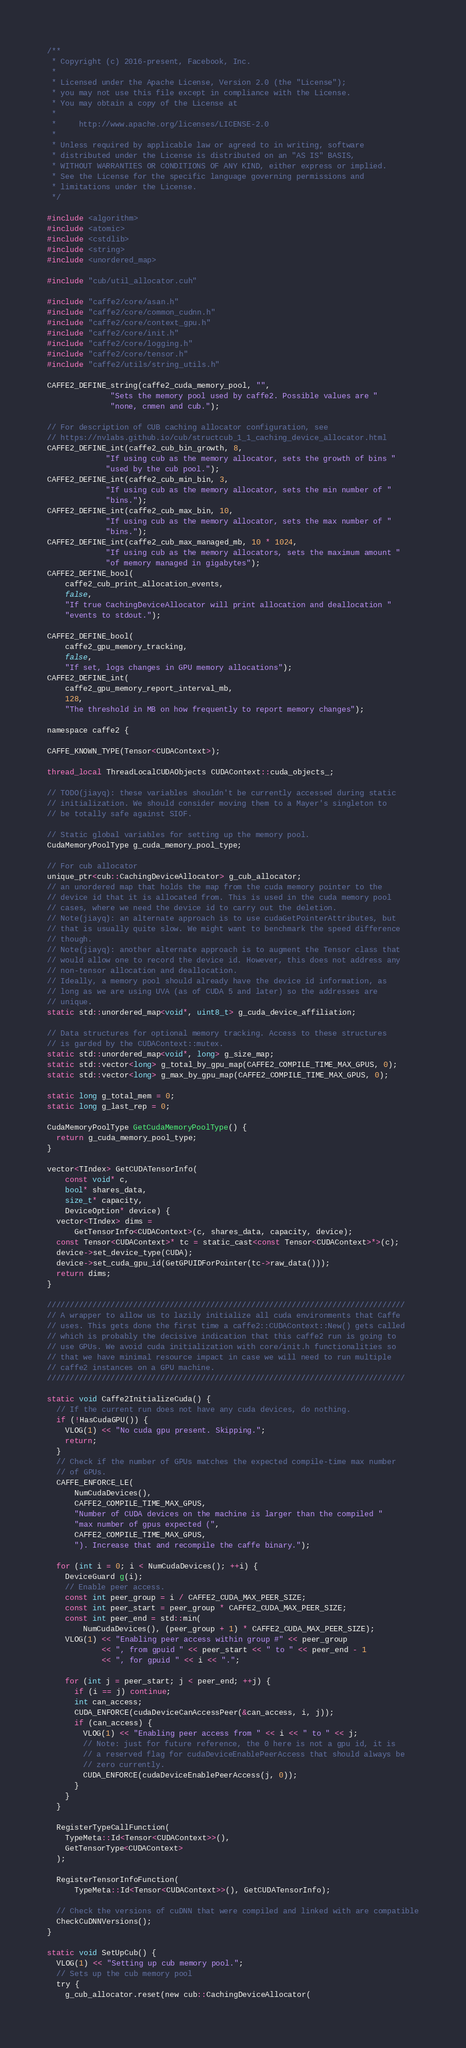Convert code to text. <code><loc_0><loc_0><loc_500><loc_500><_Cuda_>/**
 * Copyright (c) 2016-present, Facebook, Inc.
 *
 * Licensed under the Apache License, Version 2.0 (the "License");
 * you may not use this file except in compliance with the License.
 * You may obtain a copy of the License at
 *
 *     http://www.apache.org/licenses/LICENSE-2.0
 *
 * Unless required by applicable law or agreed to in writing, software
 * distributed under the License is distributed on an "AS IS" BASIS,
 * WITHOUT WARRANTIES OR CONDITIONS OF ANY KIND, either express or implied.
 * See the License for the specific language governing permissions and
 * limitations under the License.
 */

#include <algorithm>
#include <atomic>
#include <cstdlib>
#include <string>
#include <unordered_map>

#include "cub/util_allocator.cuh"

#include "caffe2/core/asan.h"
#include "caffe2/core/common_cudnn.h"
#include "caffe2/core/context_gpu.h"
#include "caffe2/core/init.h"
#include "caffe2/core/logging.h"
#include "caffe2/core/tensor.h"
#include "caffe2/utils/string_utils.h"

CAFFE2_DEFINE_string(caffe2_cuda_memory_pool, "",
              "Sets the memory pool used by caffe2. Possible values are "
              "none, cnmen and cub.");

// For description of CUB caching allocator configuration, see
// https://nvlabs.github.io/cub/structcub_1_1_caching_device_allocator.html
CAFFE2_DEFINE_int(caffe2_cub_bin_growth, 8,
             "If using cub as the memory allocator, sets the growth of bins "
             "used by the cub pool.");
CAFFE2_DEFINE_int(caffe2_cub_min_bin, 3,
             "If using cub as the memory allocator, sets the min number of "
             "bins.");
CAFFE2_DEFINE_int(caffe2_cub_max_bin, 10,
             "If using cub as the memory allocator, sets the max number of "
             "bins.");
CAFFE2_DEFINE_int(caffe2_cub_max_managed_mb, 10 * 1024,
             "If using cub as the memory allocators, sets the maximum amount "
             "of memory managed in gigabytes");
CAFFE2_DEFINE_bool(
    caffe2_cub_print_allocation_events,
    false,
    "If true CachingDeviceAllocator will print allocation and deallocation "
    "events to stdout.");

CAFFE2_DEFINE_bool(
    caffe2_gpu_memory_tracking,
    false,
    "If set, logs changes in GPU memory allocations");
CAFFE2_DEFINE_int(
    caffe2_gpu_memory_report_interval_mb,
    128,
    "The threshold in MB on how frequently to report memory changes");

namespace caffe2 {

CAFFE_KNOWN_TYPE(Tensor<CUDAContext>);

thread_local ThreadLocalCUDAObjects CUDAContext::cuda_objects_;

// TODO(jiayq): these variables shouldn't be currently accessed during static
// initialization. We should consider moving them to a Mayer's singleton to
// be totally safe against SIOF.

// Static global variables for setting up the memory pool.
CudaMemoryPoolType g_cuda_memory_pool_type;

// For cub allocator
unique_ptr<cub::CachingDeviceAllocator> g_cub_allocator;
// an unordered map that holds the map from the cuda memory pointer to the
// device id that it is allocated from. This is used in the cuda memory pool
// cases, where we need the device id to carry out the deletion.
// Note(jiayq): an alternate approach is to use cudaGetPointerAttributes, but
// that is usually quite slow. We might want to benchmark the speed difference
// though.
// Note(jiayq): another alternate approach is to augment the Tensor class that
// would allow one to record the device id. However, this does not address any
// non-tensor allocation and deallocation.
// Ideally, a memory pool should already have the device id information, as
// long as we are using UVA (as of CUDA 5 and later) so the addresses are
// unique.
static std::unordered_map<void*, uint8_t> g_cuda_device_affiliation;

// Data structures for optional memory tracking. Access to these structures
// is garded by the CUDAContext::mutex.
static std::unordered_map<void*, long> g_size_map;
static std::vector<long> g_total_by_gpu_map(CAFFE2_COMPILE_TIME_MAX_GPUS, 0);
static std::vector<long> g_max_by_gpu_map(CAFFE2_COMPILE_TIME_MAX_GPUS, 0);

static long g_total_mem = 0;
static long g_last_rep = 0;

CudaMemoryPoolType GetCudaMemoryPoolType() {
  return g_cuda_memory_pool_type;
}

vector<TIndex> GetCUDATensorInfo(
    const void* c,
    bool* shares_data,
    size_t* capacity,
    DeviceOption* device) {
  vector<TIndex> dims =
      GetTensorInfo<CUDAContext>(c, shares_data, capacity, device);
  const Tensor<CUDAContext>* tc = static_cast<const Tensor<CUDAContext>*>(c);
  device->set_device_type(CUDA);
  device->set_cuda_gpu_id(GetGPUIDForPointer(tc->raw_data()));
  return dims;
}

///////////////////////////////////////////////////////////////////////////////
// A wrapper to allow us to lazily initialize all cuda environments that Caffe
// uses. This gets done the first time a caffe2::CUDAContext::New() gets called
// which is probably the decisive indication that this caffe2 run is going to
// use GPUs. We avoid cuda initialization with core/init.h functionalities so
// that we have minimal resource impact in case we will need to run multiple
// caffe2 instances on a GPU machine.
///////////////////////////////////////////////////////////////////////////////

static void Caffe2InitializeCuda() {
  // If the current run does not have any cuda devices, do nothing.
  if (!HasCudaGPU()) {
    VLOG(1) << "No cuda gpu present. Skipping.";
    return;
  }
  // Check if the number of GPUs matches the expected compile-time max number
  // of GPUs.
  CAFFE_ENFORCE_LE(
      NumCudaDevices(),
      CAFFE2_COMPILE_TIME_MAX_GPUS,
      "Number of CUDA devices on the machine is larger than the compiled "
      "max number of gpus expected (",
      CAFFE2_COMPILE_TIME_MAX_GPUS,
      "). Increase that and recompile the caffe binary.");

  for (int i = 0; i < NumCudaDevices(); ++i) {
    DeviceGuard g(i);
    // Enable peer access.
    const int peer_group = i / CAFFE2_CUDA_MAX_PEER_SIZE;
    const int peer_start = peer_group * CAFFE2_CUDA_MAX_PEER_SIZE;
    const int peer_end = std::min(
        NumCudaDevices(), (peer_group + 1) * CAFFE2_CUDA_MAX_PEER_SIZE);
    VLOG(1) << "Enabling peer access within group #" << peer_group
            << ", from gpuid " << peer_start << " to " << peer_end - 1
            << ", for gpuid " << i << ".";

    for (int j = peer_start; j < peer_end; ++j) {
      if (i == j) continue;
      int can_access;
      CUDA_ENFORCE(cudaDeviceCanAccessPeer(&can_access, i, j));
      if (can_access) {
        VLOG(1) << "Enabling peer access from " << i << " to " << j;
        // Note: just for future reference, the 0 here is not a gpu id, it is
        // a reserved flag for cudaDeviceEnablePeerAccess that should always be
        // zero currently.
        CUDA_ENFORCE(cudaDeviceEnablePeerAccess(j, 0));
      }
    }
  }

  RegisterTypeCallFunction(
    TypeMeta::Id<Tensor<CUDAContext>>(),
    GetTensorType<CUDAContext>
  );

  RegisterTensorInfoFunction(
      TypeMeta::Id<Tensor<CUDAContext>>(), GetCUDATensorInfo);

  // Check the versions of cuDNN that were compiled and linked with are compatible
  CheckCuDNNVersions();
}

static void SetUpCub() {
  VLOG(1) << "Setting up cub memory pool.";
  // Sets up the cub memory pool
  try {
    g_cub_allocator.reset(new cub::CachingDeviceAllocator(</code> 